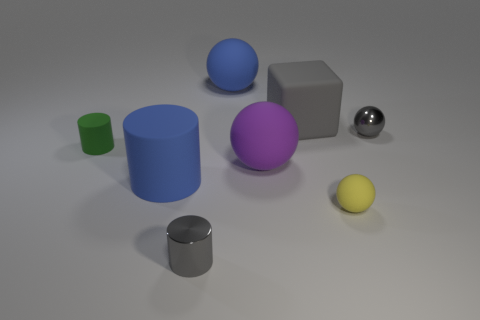There is a shiny object that is behind the tiny gray metal object that is in front of the tiny green rubber cylinder; how many gray things are in front of it?
Make the answer very short. 1. What number of small metal spheres are behind the big purple thing?
Offer a very short reply. 1. What is the color of the other matte thing that is the same shape as the tiny green object?
Offer a very short reply. Blue. There is a cylinder that is in front of the purple matte ball and behind the tiny yellow rubber ball; what is its material?
Offer a very short reply. Rubber. Is the size of the gray metal cylinder that is in front of the shiny ball the same as the big blue cylinder?
Keep it short and to the point. No. What is the material of the large blue sphere?
Your answer should be compact. Rubber. There is a tiny cylinder that is in front of the purple rubber sphere; what is its color?
Your answer should be very brief. Gray. What number of large things are either balls or green things?
Your answer should be very brief. 2. Does the small cylinder to the right of the small green cylinder have the same color as the small shiny thing that is on the right side of the small yellow thing?
Ensure brevity in your answer.  Yes. How many other things are there of the same color as the tiny rubber ball?
Provide a short and direct response. 0. 